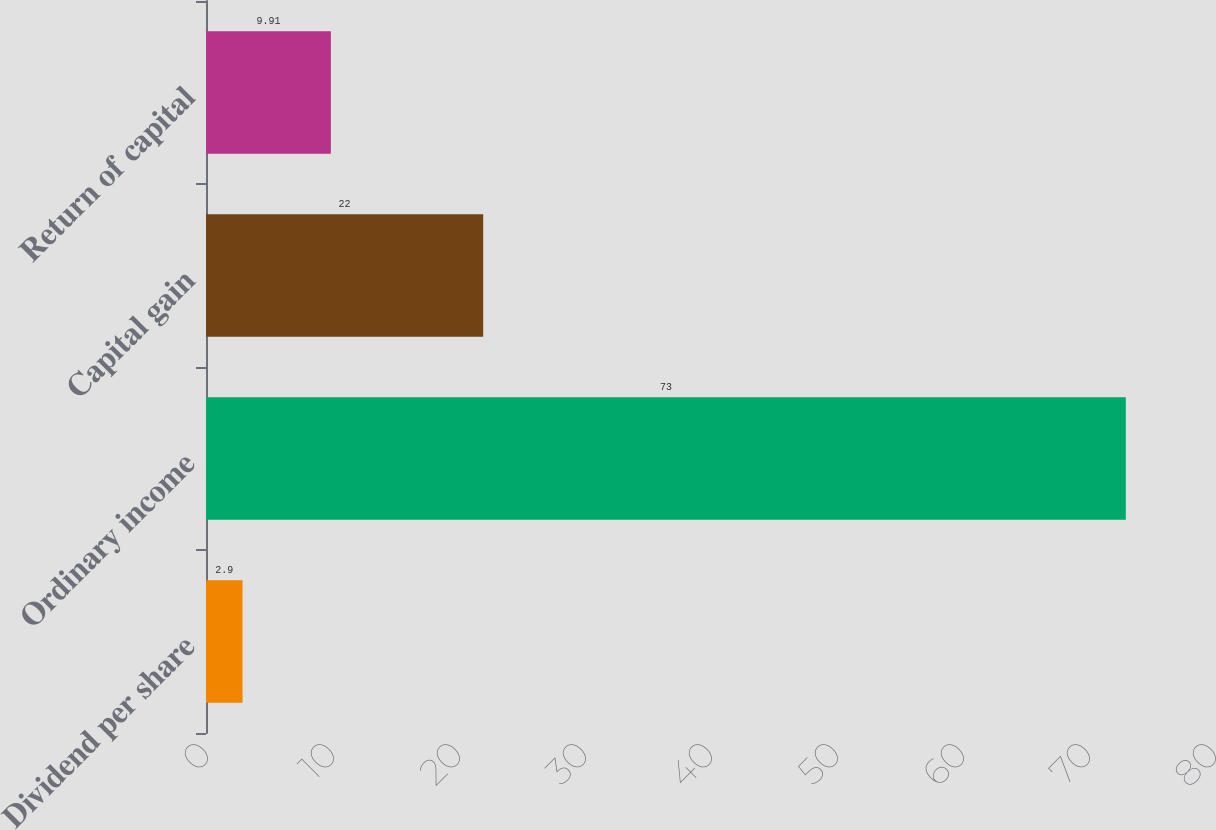Convert chart. <chart><loc_0><loc_0><loc_500><loc_500><bar_chart><fcel>Dividend per share<fcel>Ordinary income<fcel>Capital gain<fcel>Return of capital<nl><fcel>2.9<fcel>73<fcel>22<fcel>9.91<nl></chart> 